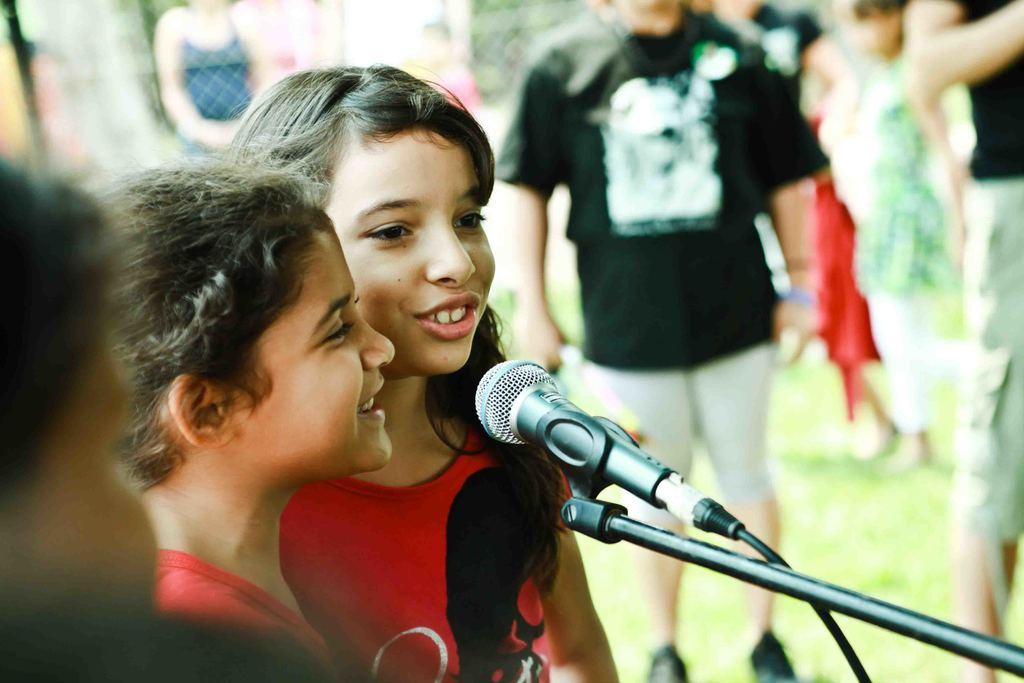How many girls are in the image? There are two girls in the image. What are the girls doing in the image? The girls are in front of a microphone. What else can be seen in the image besides the girls? There is a rod and wire, people, grass, and a mesh in the image. What type of loaf can be seen on the floor in the image? There is no loaf present in the image, and the floor is not visible. --- Facts: 1. There is a car in the image. 2. The car is red. 3. The car has four wheels. 4. There is a road in the image. 5. The road is paved. Absurd Topics: parrot, sand, mountain Conversation: What is the main subject of the image? The main subject of the image is a car. What color is the car? The car is red. How many wheels does the car have? The car has four wheels. What type of surface is the car on? There is a road in the image, and it is paved. Reasoning: Let's think step by step in order to produce the conversation. We start by identifying the main subject of the image, which is the car. Then, we describe specific features of the car, such as its color and the number of wheels. Next, we observe the setting in which the car is located, noting that it is on a paved road. Each question is designed to elicit a specific detail about the image that is known from the provided facts. Absurd Question/Answer: Can you see a parrot perched on the mountain in the image? There is no mountain or parrot present in the image. 